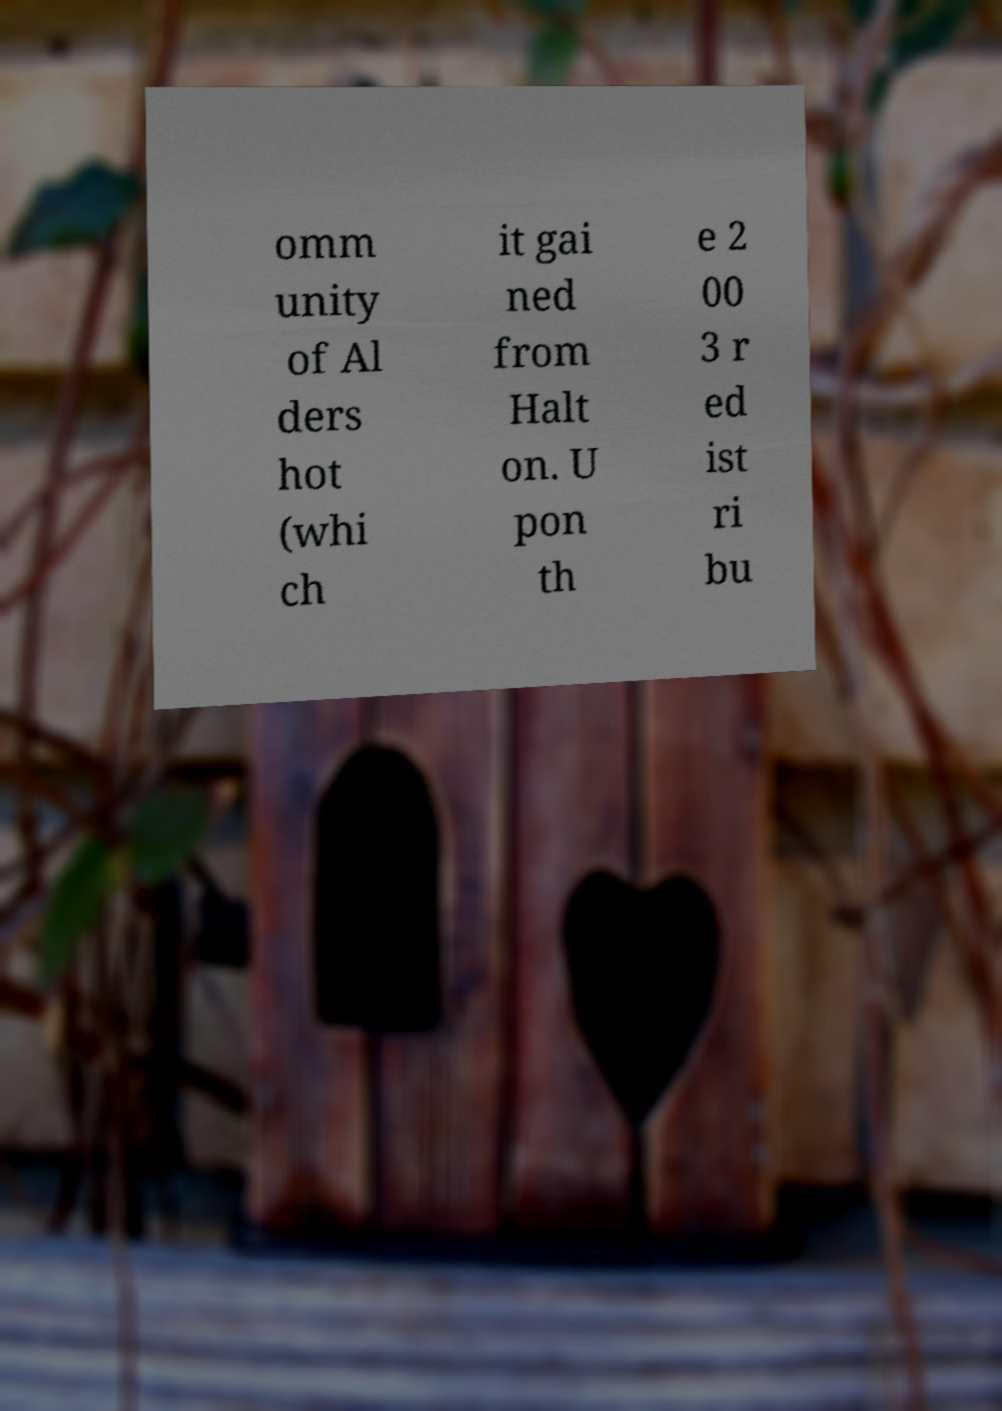I need the written content from this picture converted into text. Can you do that? omm unity of Al ders hot (whi ch it gai ned from Halt on. U pon th e 2 00 3 r ed ist ri bu 